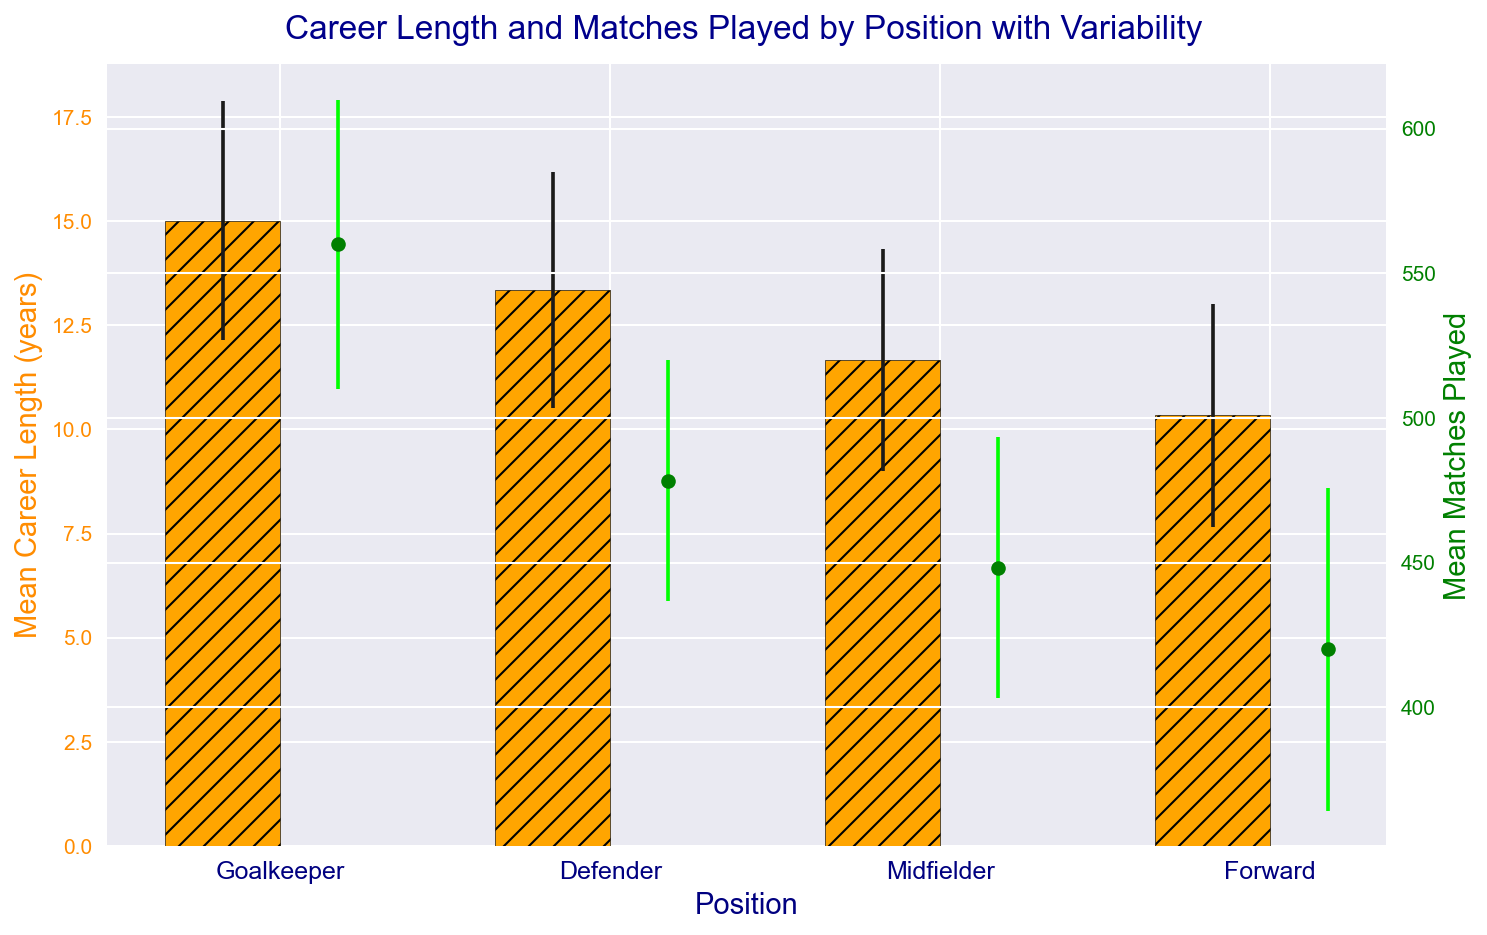What position has the longest mean career length? By looking at the bars representing career length in the figure, the one with the tallest bar indicates the longest mean career length. The color and labeling show that it's "Goalkeeper."
Answer: Goalkeeper Which position has the highest variability in the number of matches played? For variability, we observe the error bars on the matches played indicators (green dots). The position with the longest error bars represents the highest variability. This is "Forward."
Answer: Forward What’s the difference in average career length between Goalkeepers and Forwards? Calculate the average career length for Goalkeepers and Forwards and find the difference: For Goalkeepers, it's about 15, and for Forwards, it's about 10. The difference is 15 - 10 = 5 years.
Answer: 5 years Which position shows more consistency in career length, based on standard deviation? Consistency is reflected by shorter error bars (less variability). Comparing the error bars for career length, it appears "Defender" has one of the shortest error bars.
Answer: Defender How many more matches do Goalkeepers play on average compared to Forwards? Find the mean matches played for Goalkeepers and Forwards: Goalkeepers play about 560 matches, and Forwards play about 420 matches. The difference is 560 - 420 = 140 matches.
Answer: 140 matches Is the mean career length for Defenders longer than that for Midfielders? Compare the heights of the bars for Defenders and Midfielders. Defenders have taller bars, indicating a longer career.
Answer: Yes Which position has the least mean career length and by how much? Identify the position with the shortest bar for career length. That's "Forward" with about 10 years. Subtract this from the next shortest (Midfielder, about 12). The difference is 12 - 10 = 2 years.
Answer: Forward, 2 years What’s the mean matches played by Midfielders compared to Goalkeepers? Check the green dots for these positions. Midfielders play about 450 matches on average while Goalkeepers play about 560 matches.
Answer: Goalkeepers play more What is the average standard deviation of career lengths across all positions? Add the standard deviations of career lengths (3.2, 2.8, 3.0, 2.5, 2.9, 3.1, 2.7, 2.8, 2.5, 2.6, 2.3, 2.7 = 33.1), then divide by the number of positions (12). 33.1 / 12 = 2.76.
Answer: 2.76 Do Goalkeepers have the highest match play variability compared to other positions? Check the length of the error bars for match plays. Goalkeepers and Forwards seem to have significant bars, but Forwards are higher. So, they don’t have the highest variability.
Answer: No 